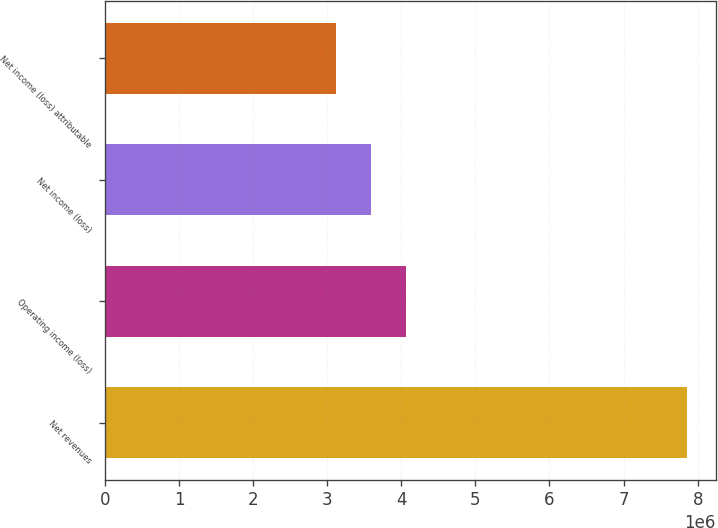Convert chart to OTSL. <chart><loc_0><loc_0><loc_500><loc_500><bar_chart><fcel>Net revenues<fcel>Operating income (loss)<fcel>Net income (loss)<fcel>Net income (loss) attributable<nl><fcel>7.84931e+06<fcel>4.06157e+06<fcel>3.5881e+06<fcel>3.11464e+06<nl></chart> 